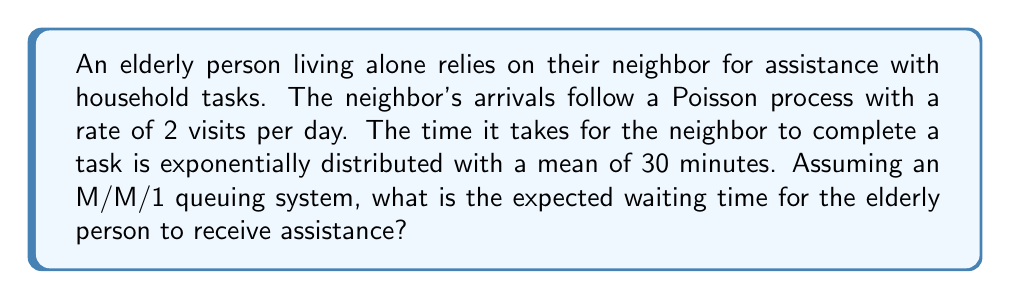Help me with this question. To solve this problem, we'll use the M/M/1 queuing theory model:

1. Define the parameters:
   $\lambda$ = arrival rate = 2 visits per day
   $\mu$ = service rate = 48 services per day (since 1 day = 24 hours, and mean service time is 0.5 hours)

2. Calculate the utilization factor $\rho$:
   $$\rho = \frac{\lambda}{\mu} = \frac{2}{48} = \frac{1}{24}$$

3. The expected waiting time in the queue ($W_q$) for an M/M/1 system is given by:
   $$W_q = \frac{\rho}{\mu - \lambda}$$

4. Substitute the values:
   $$W_q = \frac{\frac{1}{24}}{48 - 2} = \frac{\frac{1}{24}}{46}$$

5. Simplify:
   $$W_q = \frac{1}{24 \times 46} = \frac{1}{1104}$$ days

6. Convert to minutes:
   $$W_q = \frac{1}{1104} \times 24 \times 60 = \frac{1440}{1104} \approx 1.30$$ minutes

Therefore, the expected waiting time for the elderly person to receive assistance is approximately 1.30 minutes.
Answer: 1.30 minutes 